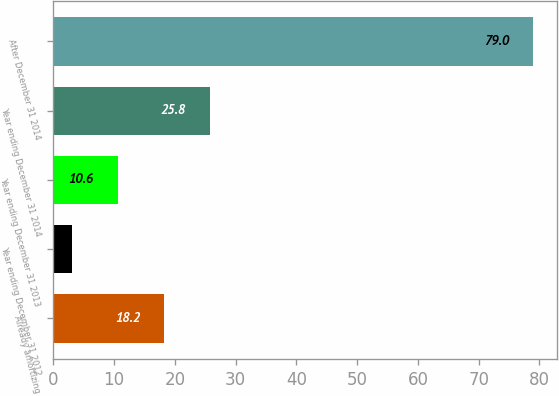Convert chart to OTSL. <chart><loc_0><loc_0><loc_500><loc_500><bar_chart><fcel>Already amortizing<fcel>Year ending December 31 2012<fcel>Year ending December 31 2013<fcel>Year ending December 31 2014<fcel>After December 31 2014<nl><fcel>18.2<fcel>3<fcel>10.6<fcel>25.8<fcel>79<nl></chart> 